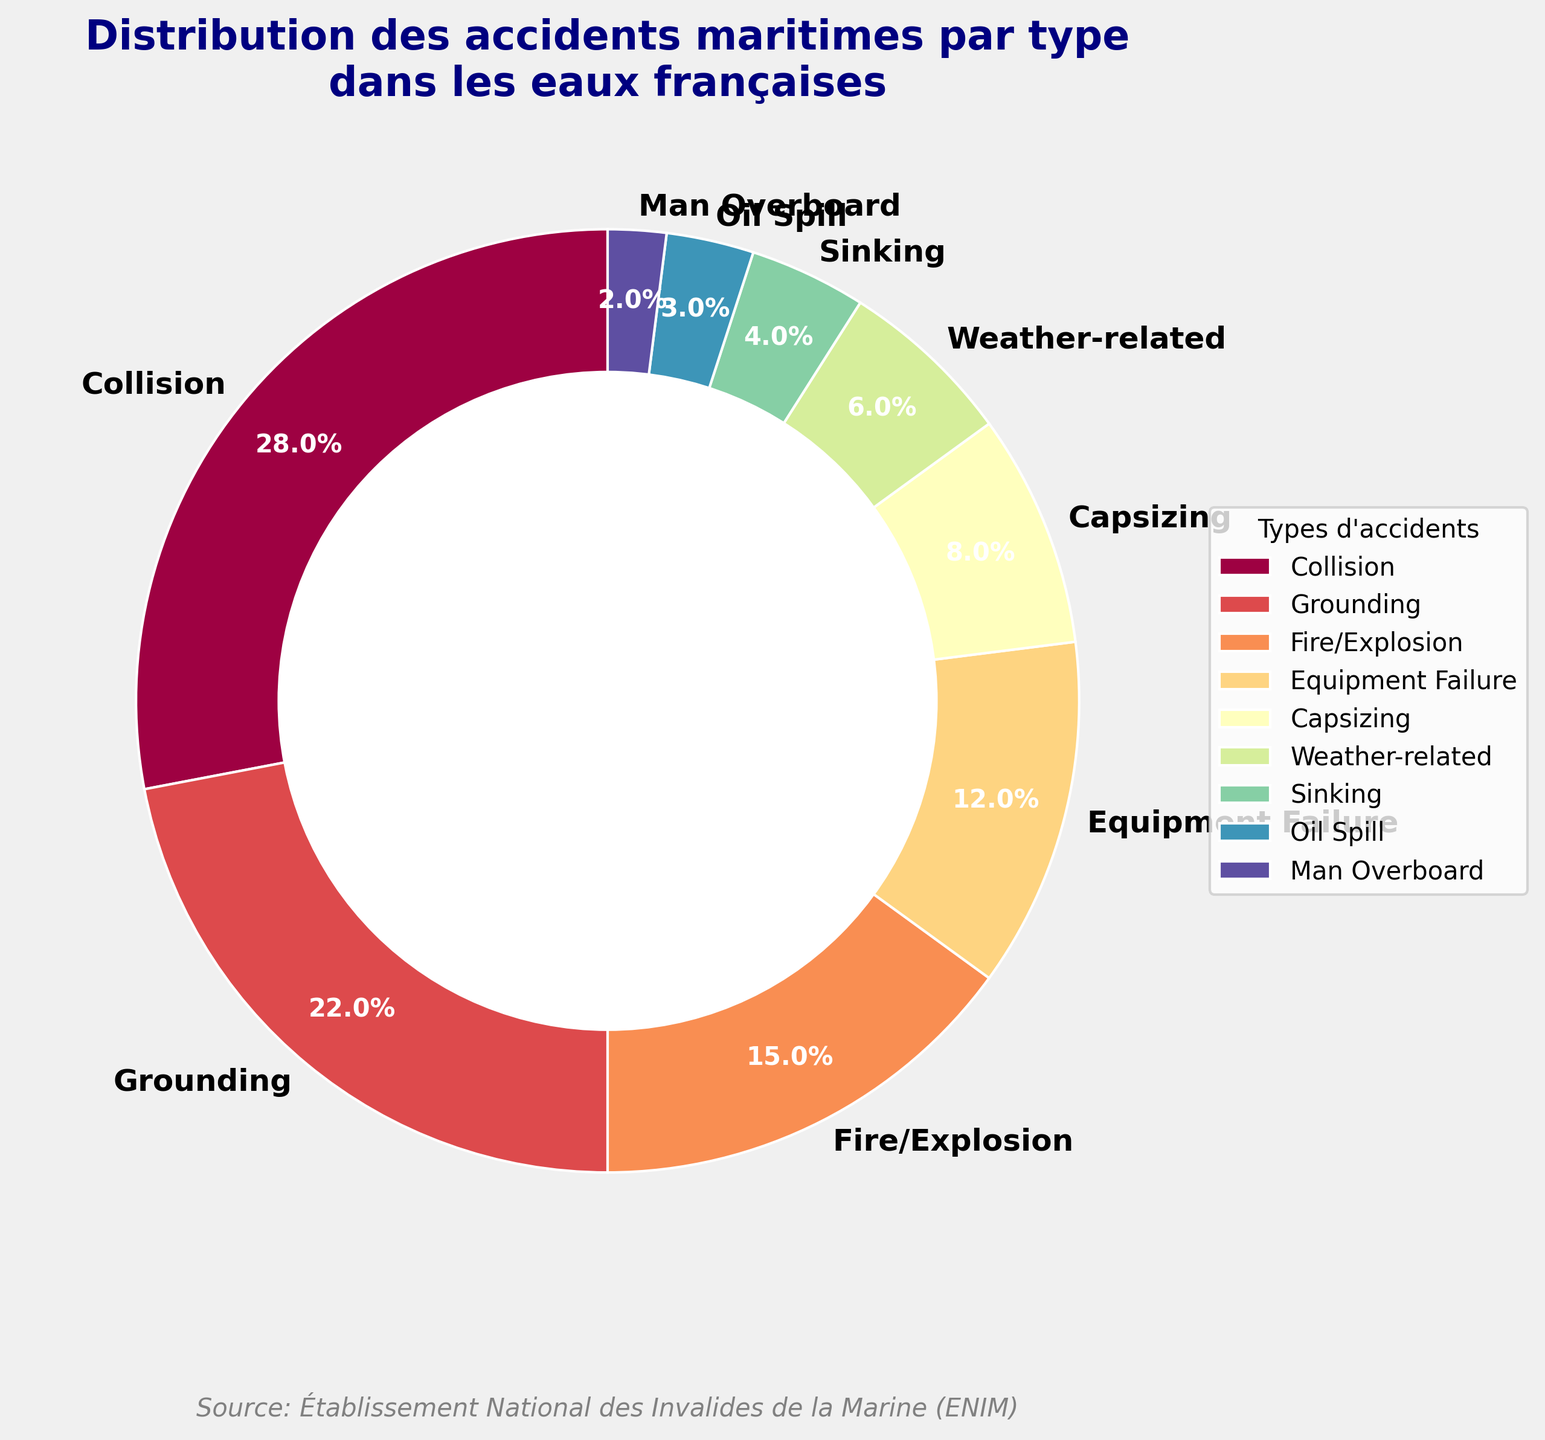Quelle catégorie d'accident maritime représente le pourcentage le plus élevé ? En examinant les sections du graphique, la plus grande correspond au pourcentage de 28 %, identifiée par l'étiquette "Collision".
Answer: Collision (28 %) Quelle part combinée des accidents maritimes est attribuée aux "Incendies/Explosions" et aux "Échouements" ? Sommons les pourcentages des "Incendies/Explosions" (15 %) et des "Échouements" (22 %). Donc, 15 + 22 = 37 %.
Answer: 37 % Combien de types d'accidents maritimes ont une part inférieure à 10 % ? Identifier les sections du graphique avec des valeurs inférieures à 10 % : "Renversement" (8 %), "Relatifs au temps" (6 %), "Naufrage" (4 %), "Déversement d'huile" (3 %), et "Homme à la mer" (2 %). Il y a cinq sections dans cette catégorie.
Answer: Cinq (5) Par rapport aux "Défaillances d'équipement", quelle catégorie d'accident maritime représente une plus grande proportion, et de combien ? "Défaillances d'équipement" représente 12 %. "Collisions" est la catégorie au-dessus avec 28 %. La différence est 28 - 12 = 16 %.
Answer: Collision de 16 % plus grande Quelle est la différence de pourcentage entre l'accident de "Renversement" et celui de "Relatifs au temps" ? "Renversement" est à 8 % et "Relatifs au temps" est à 6 %. La différence est 8 - 6 = 2 %.
Answer: 2 % Quels types d'accidents maritimes ont des sections jaunes sur le graphique ? Les sections du graphique en couleur jaune et nuances montrent "Relatifs au temps" et "Naufrage".
Answer: Relatifs au temps et Naufrage Dans quelle section du graphique se trouve l'étiquette "38.0%", et à quel type d'accident correspond-elle ? En recherchant l'étiquette avec le texte "38.0%", elle est visible dans la section pour "Siège".
Answer: Siège Quel est le pourcentage total de "Naufrages" et des "Hommes à la mer" par rapport à l'ensemble des accidents maritimes ? Additionnons les pourcentages des "Naufrages" (4 %) et des "Hommes à la mer" (2 %). Total : 4 + 2 = 6 %.
Answer: 6 % Quelle catégorie d'accident a la plus petite part sur ce graphique et quel est son pourcentage ? La catégorie avec la plus petite section visible dans le graphique est "Homme à la mer", ce qui est 2 %.
Answer: Homme à la mer (2 %) Quel pourcentage cumulé représentent les trois plus grandes catégories d'accidents maritimes ? Les trois plus grandes catégories par pourcentage sont : "Collision" (28 %), "Échouement" (22 %), et "Incendies/Explosions" (15 %). La somme est 28 + 22 + 15 = 65 %.
Answer: 65 % 